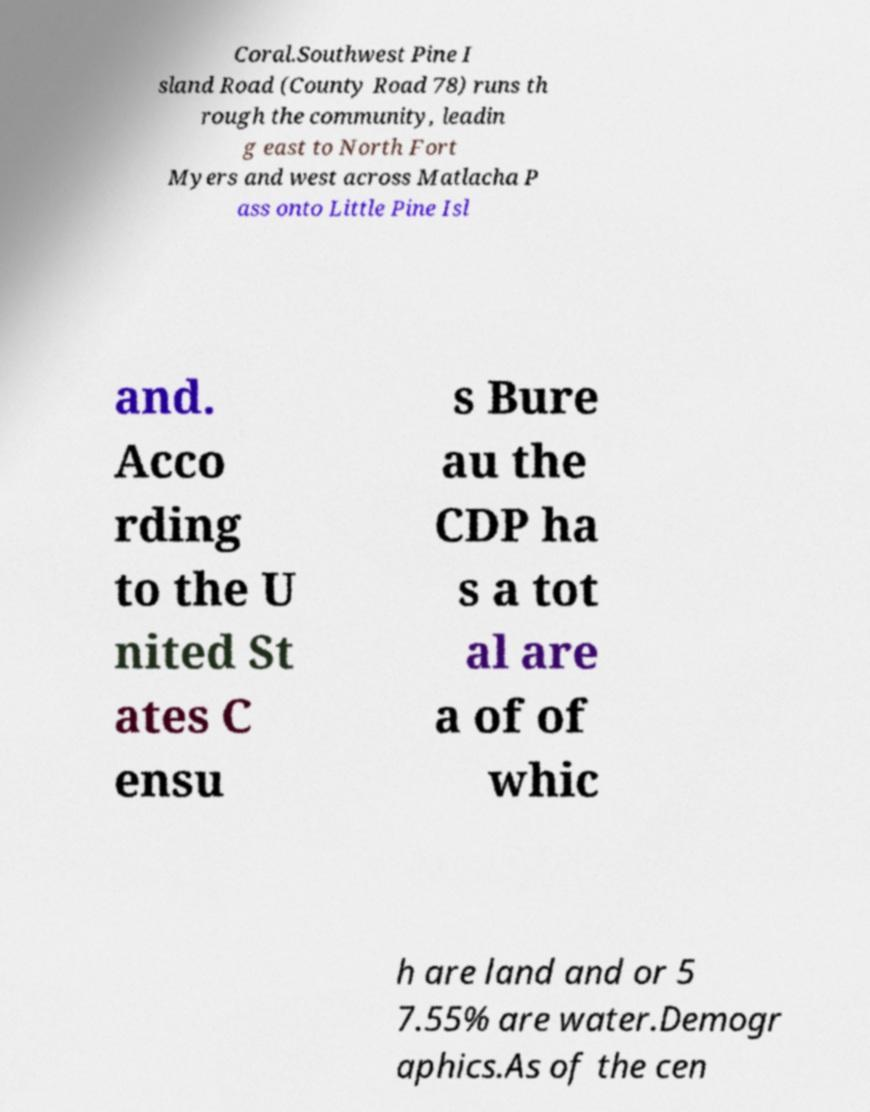There's text embedded in this image that I need extracted. Can you transcribe it verbatim? Coral.Southwest Pine I sland Road (County Road 78) runs th rough the community, leadin g east to North Fort Myers and west across Matlacha P ass onto Little Pine Isl and. Acco rding to the U nited St ates C ensu s Bure au the CDP ha s a tot al are a of of whic h are land and or 5 7.55% are water.Demogr aphics.As of the cen 